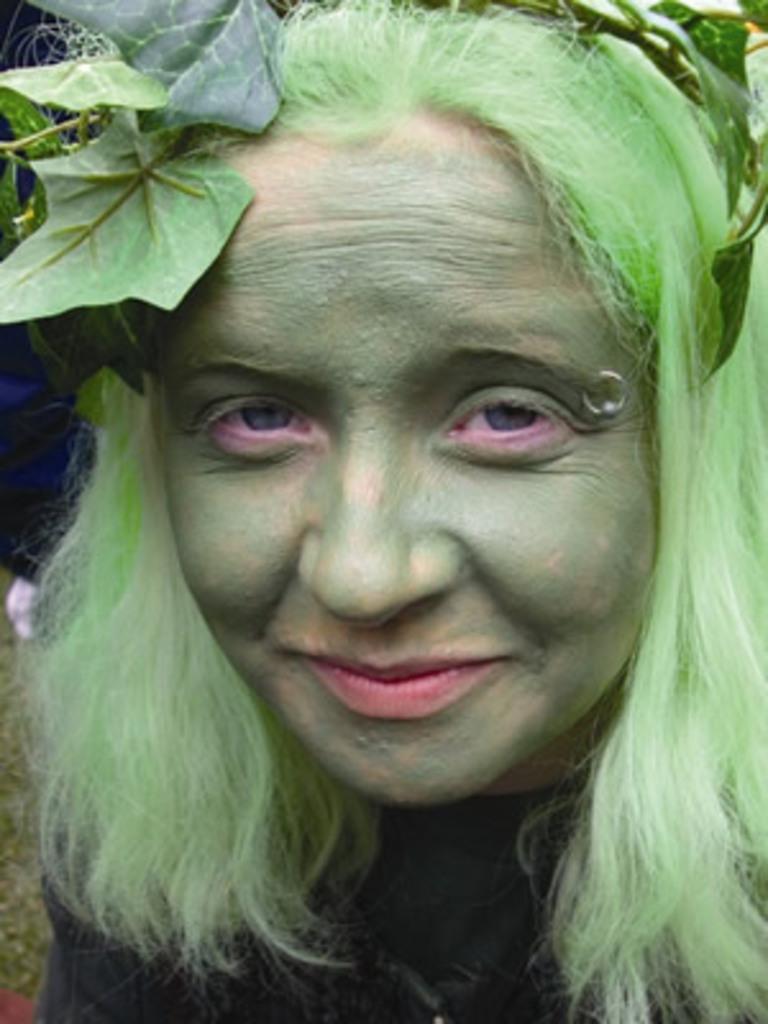Please provide a concise description of this image. The woman in the middle of the picture wearing a black T-shirt is posing for the photo. She is smiling. The face and hairs of her are in green color. Behind her, we see a tree or a plant. 